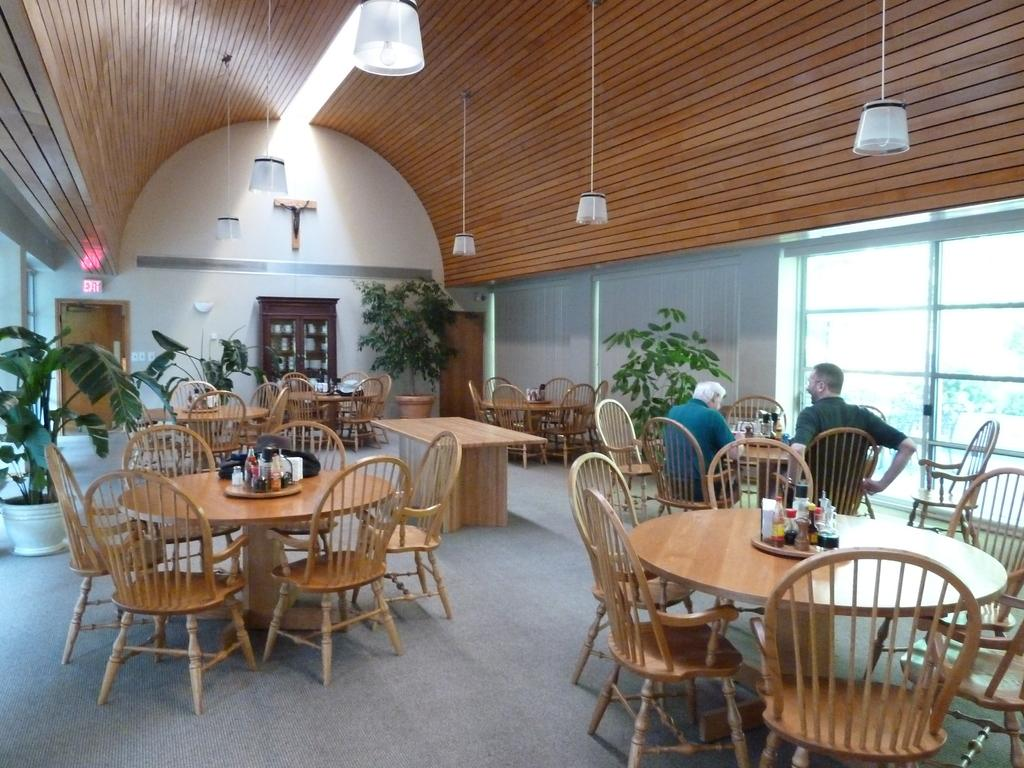What type of furniture is present in the image? There are chairs and tables in the image. What else can be seen in the image besides furniture? There are plants, people seated on the chairs, a cupboard, a sign board on a door, and a glass window in the image. How many ants can be seen crawling on the ground in the image? There are no ants present in the image, and the ground is not visible. 